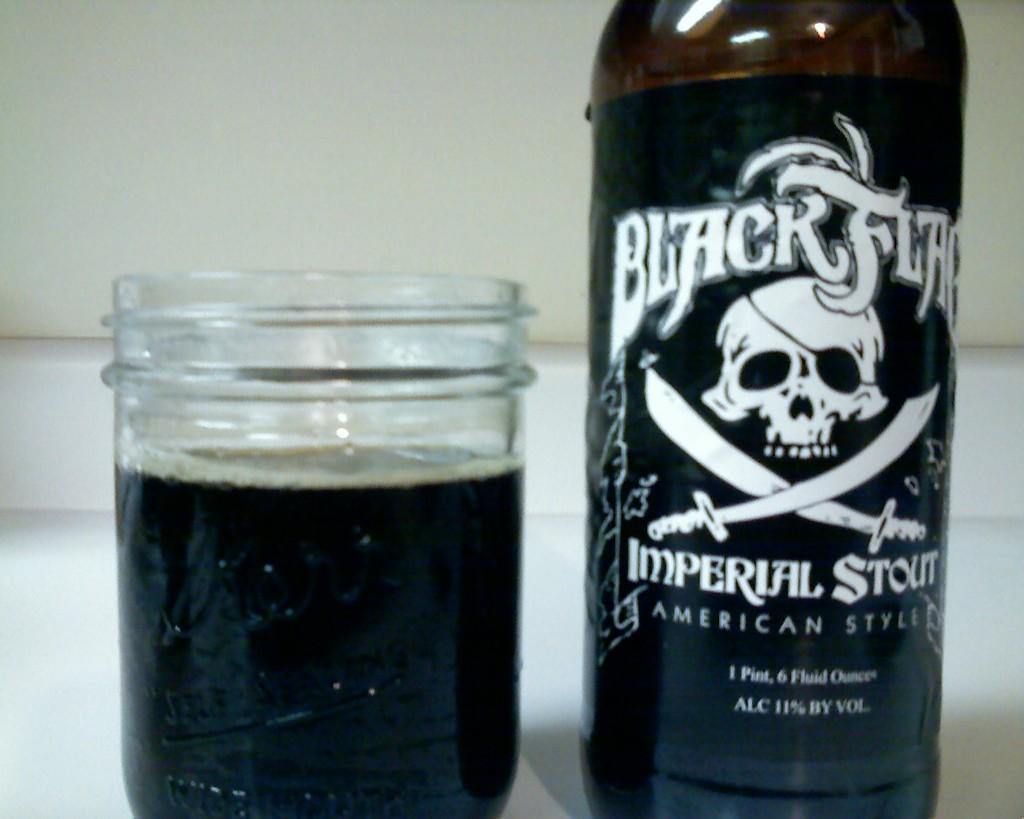Describe this image in one or two sentences. In the picture we can see a bottle, a glass, a bottle is full of wine and a glass is full of wine. In the background we can see a white wall. On the bottle it is written as black flag with two swords. 